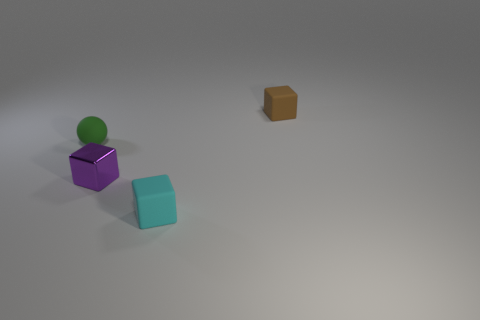Add 4 rubber spheres. How many objects exist? 8 Subtract all spheres. How many objects are left? 3 Add 4 green balls. How many green balls are left? 5 Add 1 tiny shiny cubes. How many tiny shiny cubes exist? 2 Subtract 1 cyan cubes. How many objects are left? 3 Subtract all brown objects. Subtract all shiny objects. How many objects are left? 2 